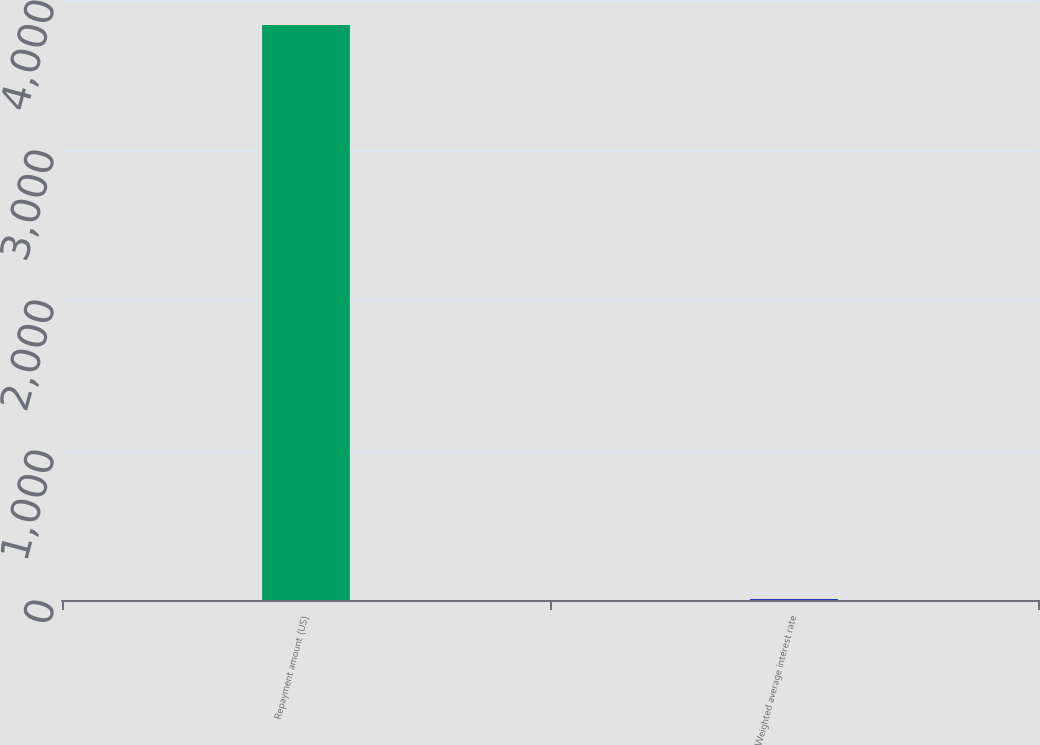Convert chart. <chart><loc_0><loc_0><loc_500><loc_500><bar_chart><fcel>Repayment amount (US)<fcel>Weighted average interest rate<nl><fcel>3834<fcel>6.9<nl></chart> 